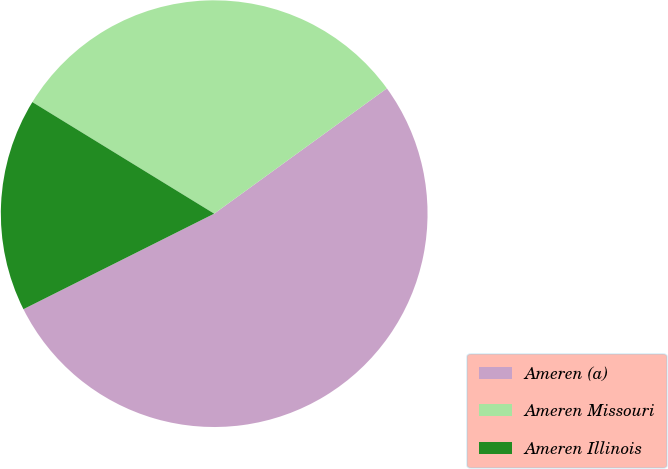Convert chart. <chart><loc_0><loc_0><loc_500><loc_500><pie_chart><fcel>Ameren (a)<fcel>Ameren Missouri<fcel>Ameren Illinois<nl><fcel>52.6%<fcel>31.25%<fcel>16.15%<nl></chart> 